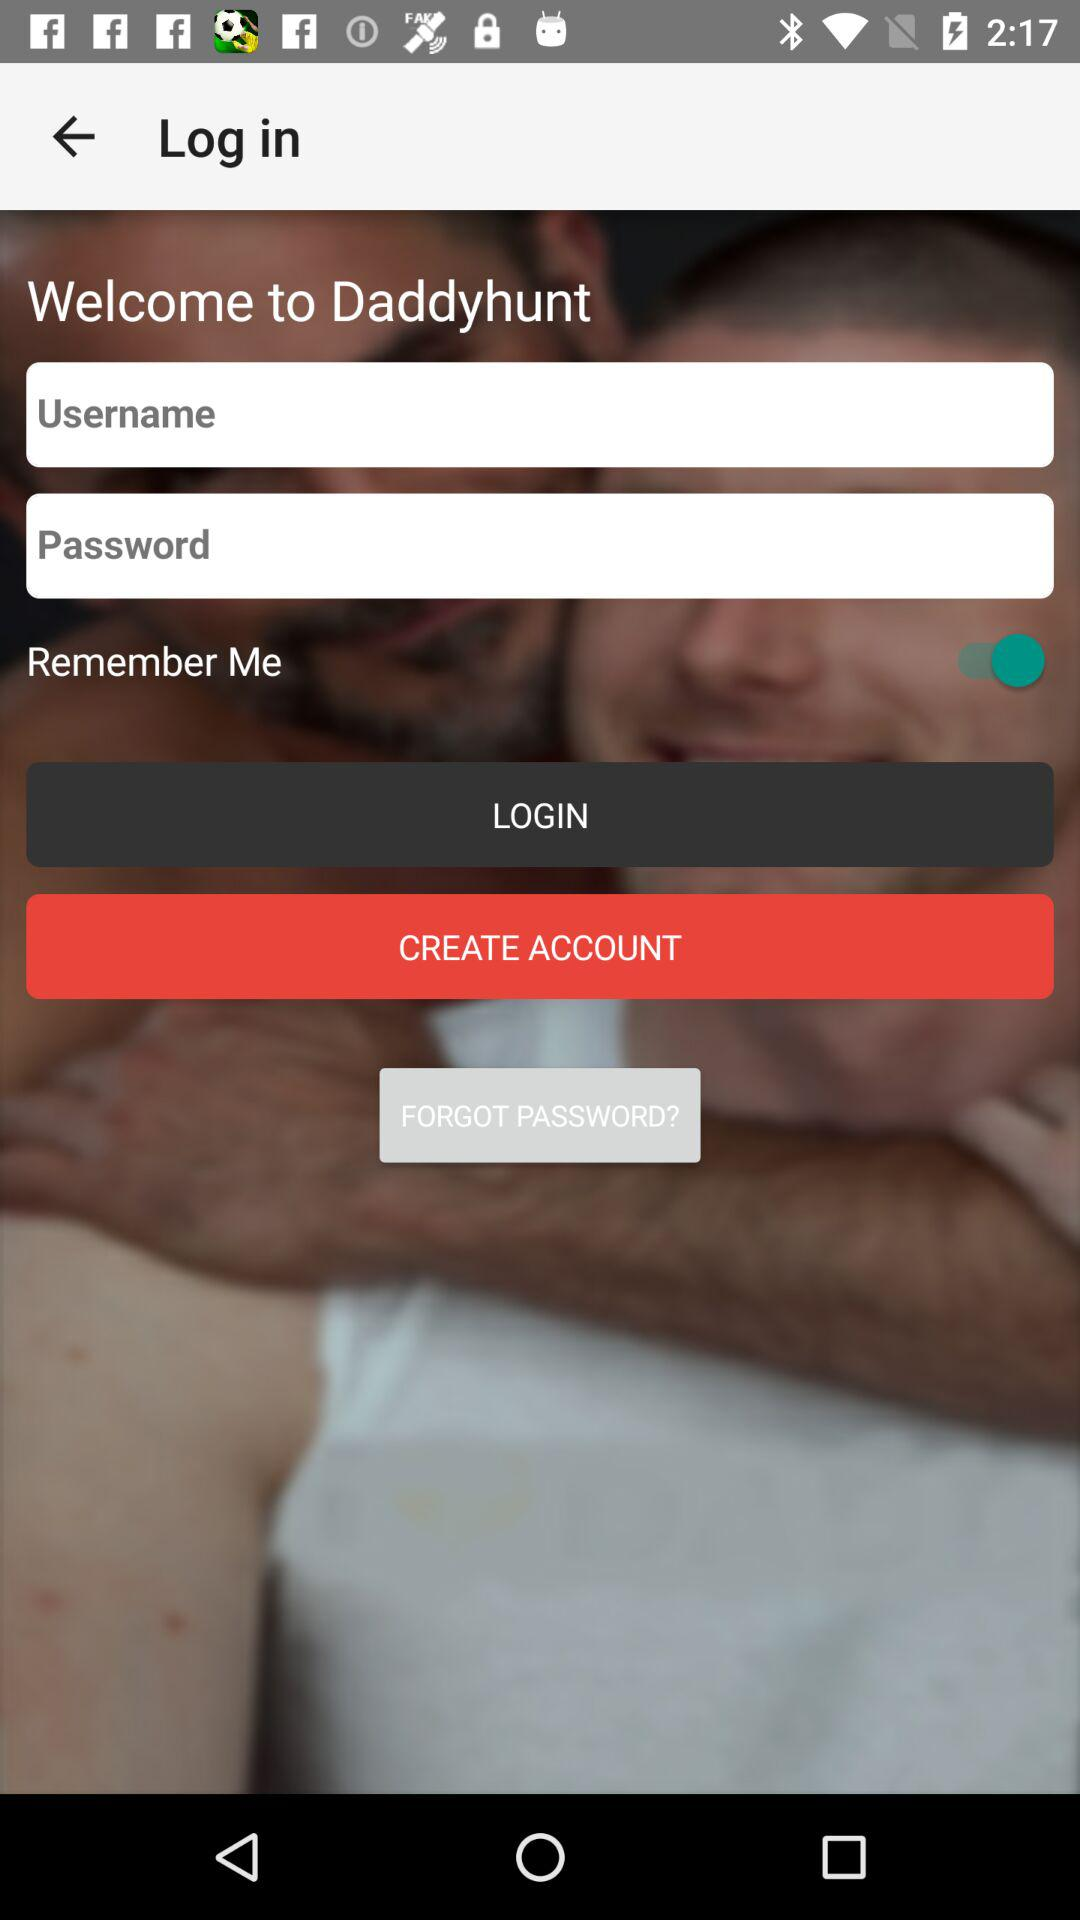What is the app name? The app name is "Daddyhunt". 